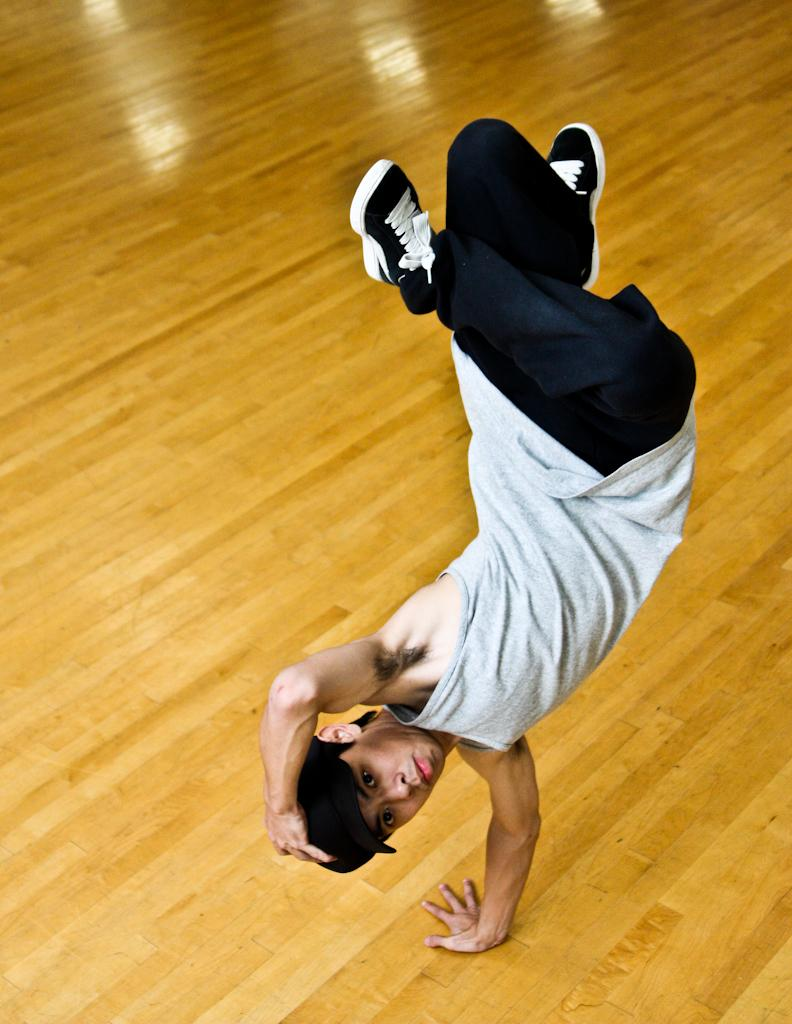What is happening in the image? There is a person in the image who is performing on the floor. Can you describe the person's activity in more detail? Unfortunately, the specific activity cannot be determined from the provided facts. Is the person alone in the image? The provided facts do not mention any other people in the image. What type of iron is being used by the person in the image? There is no iron present in the image. Can you tell me a joke that the person is telling in the image? There is no information about the person telling a joke in the image. 